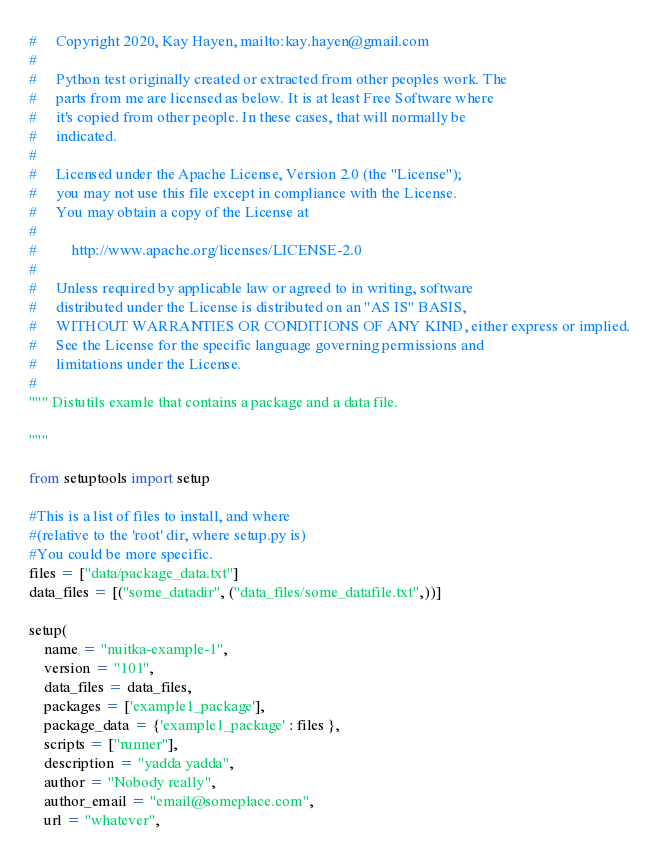Convert code to text. <code><loc_0><loc_0><loc_500><loc_500><_Python_>#     Copyright 2020, Kay Hayen, mailto:kay.hayen@gmail.com
#
#     Python test originally created or extracted from other peoples work. The
#     parts from me are licensed as below. It is at least Free Software where
#     it's copied from other people. In these cases, that will normally be
#     indicated.
#
#     Licensed under the Apache License, Version 2.0 (the "License");
#     you may not use this file except in compliance with the License.
#     You may obtain a copy of the License at
#
#         http://www.apache.org/licenses/LICENSE-2.0
#
#     Unless required by applicable law or agreed to in writing, software
#     distributed under the License is distributed on an "AS IS" BASIS,
#     WITHOUT WARRANTIES OR CONDITIONS OF ANY KIND, either express or implied.
#     See the License for the specific language governing permissions and
#     limitations under the License.
#
""" Distutils examle that contains a package and a data file.

"""

from setuptools import setup

#This is a list of files to install, and where
#(relative to the 'root' dir, where setup.py is)
#You could be more specific.
files = ["data/package_data.txt"]
data_files = [("some_datadir", ("data_files/some_datafile.txt",))]

setup(
    name = "nuitka-example-1",
    version = "101",
    data_files = data_files,
    packages = ['example1_package'],
    package_data = {'example1_package' : files },
    scripts = ["runner"],
    description = "yadda yadda",
    author = "Nobody really",
    author_email = "email@someplace.com",
    url = "whatever",</code> 